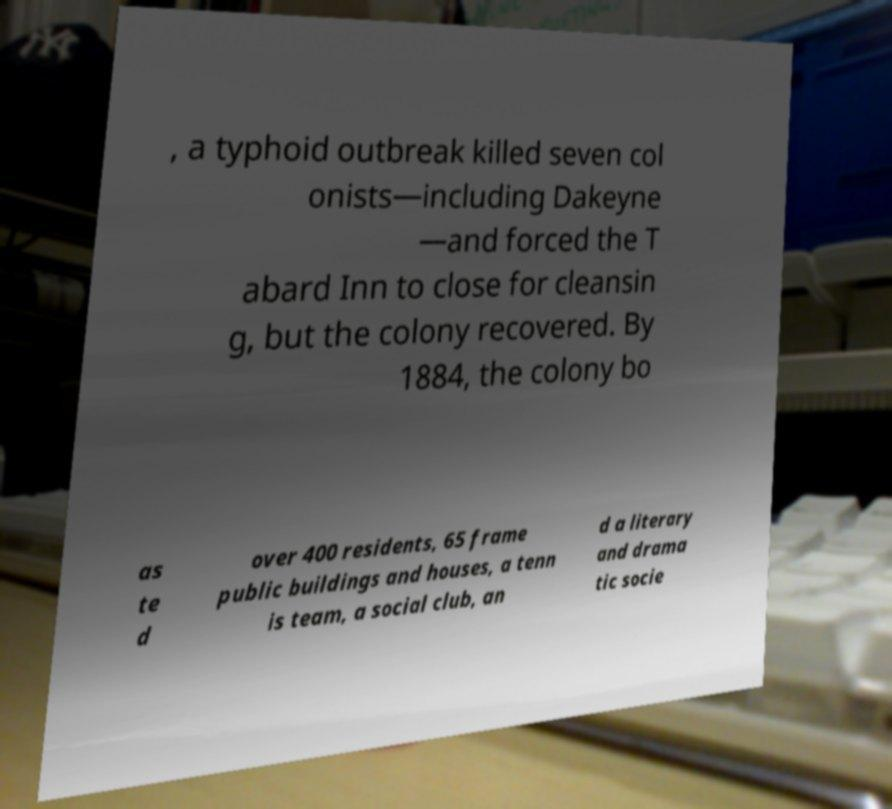Could you extract and type out the text from this image? , a typhoid outbreak killed seven col onists—including Dakeyne —and forced the T abard Inn to close for cleansin g, but the colony recovered. By 1884, the colony bo as te d over 400 residents, 65 frame public buildings and houses, a tenn is team, a social club, an d a literary and drama tic socie 